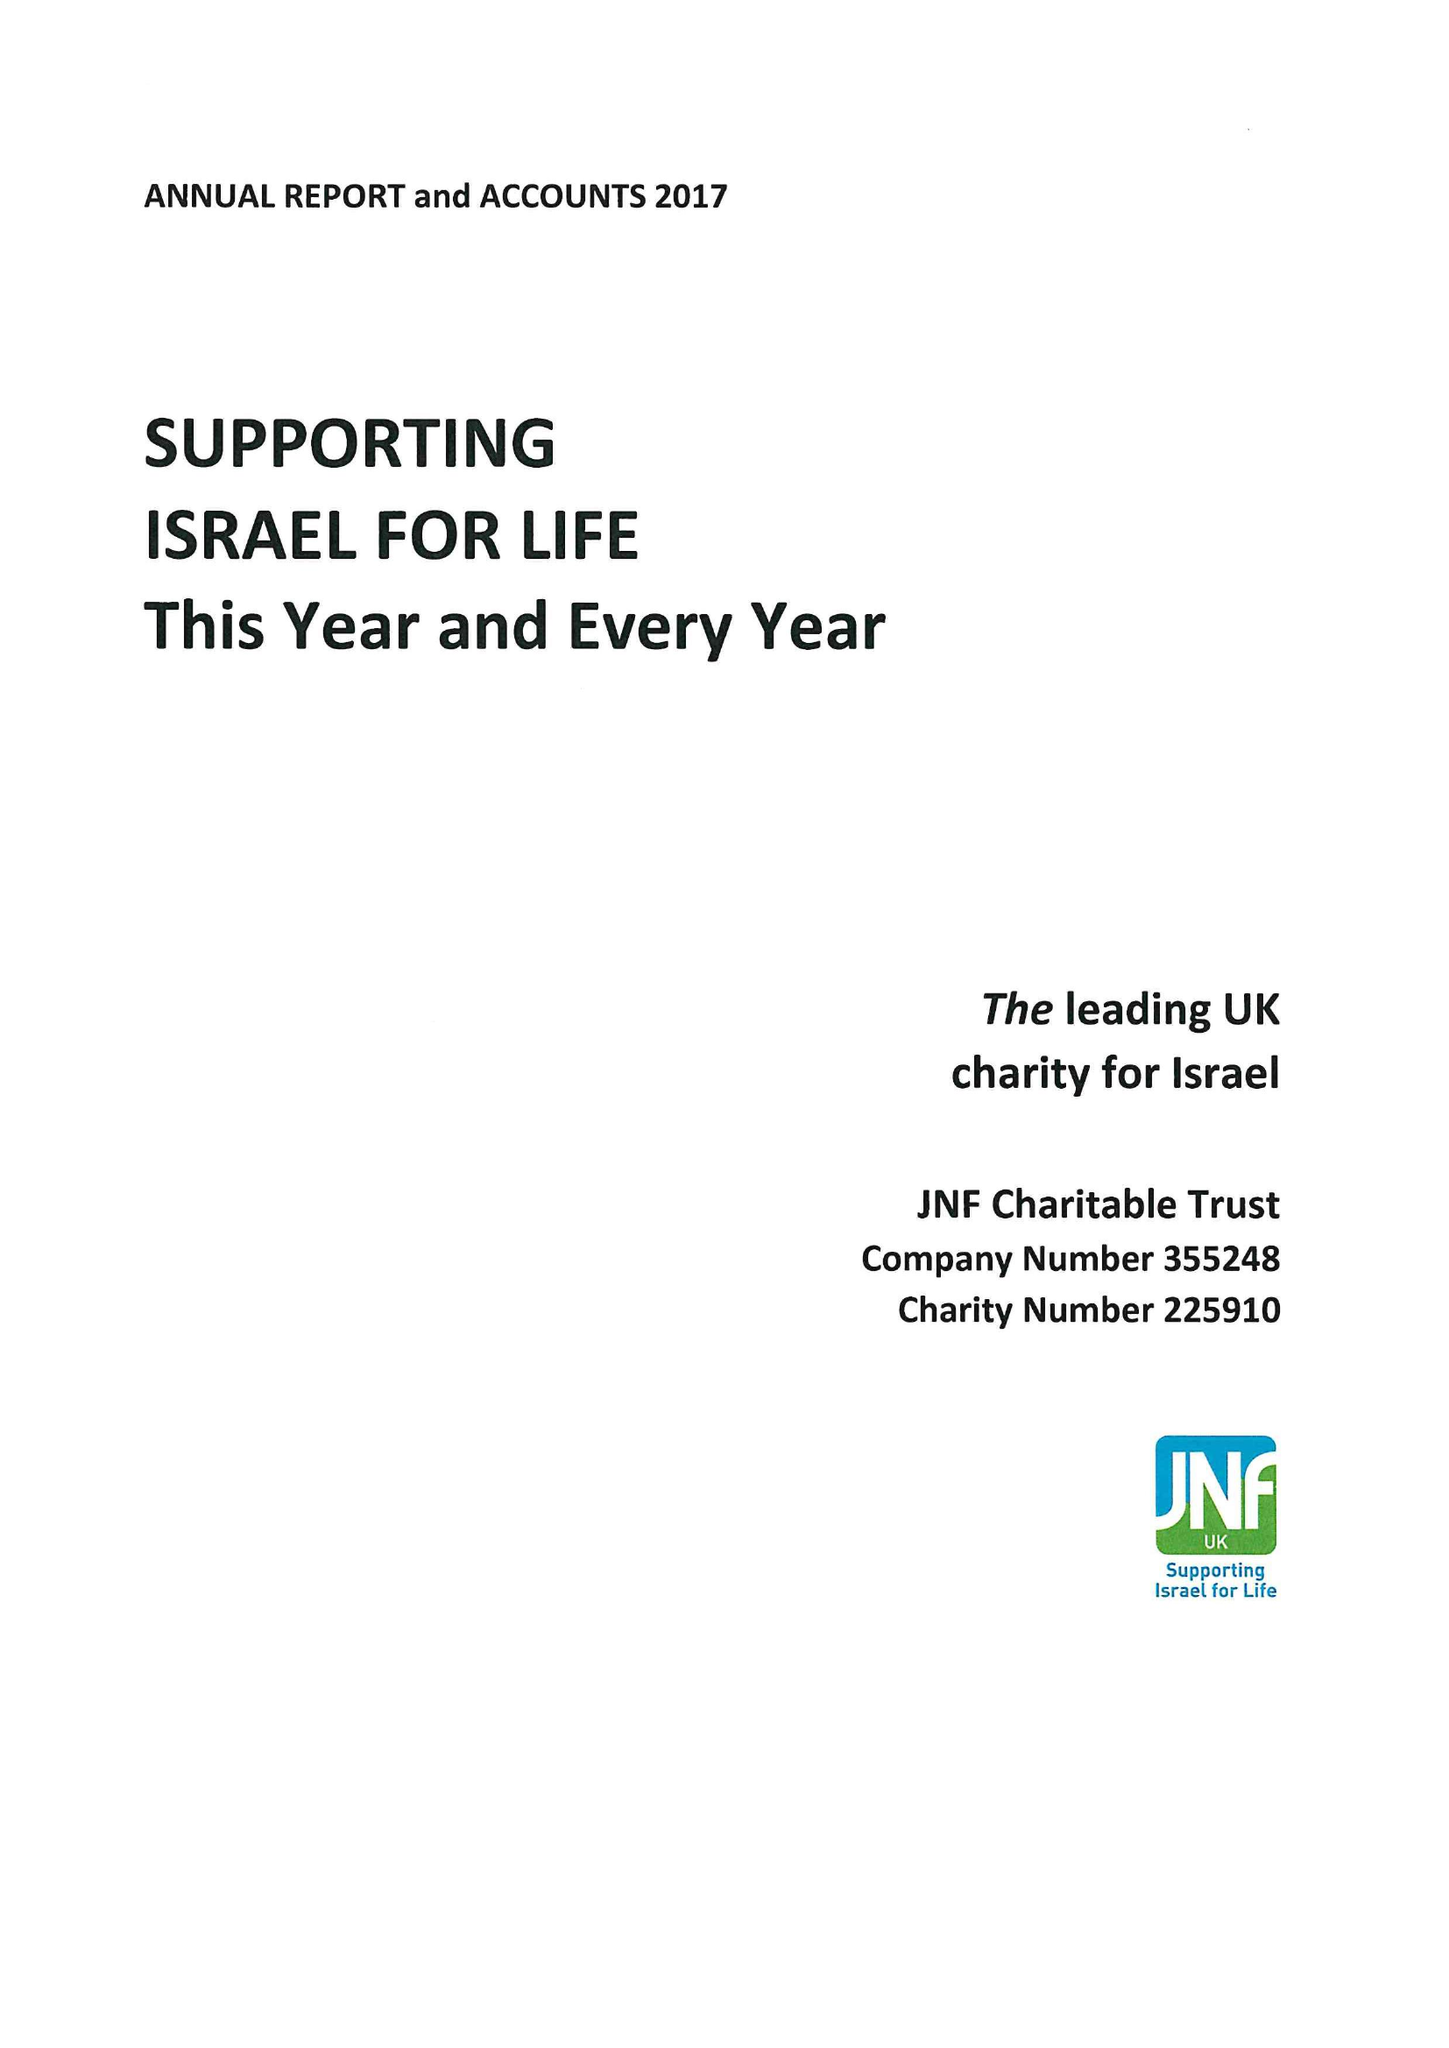What is the value for the address__street_line?
Answer the question using a single word or phrase. 154 BRENT STREET 